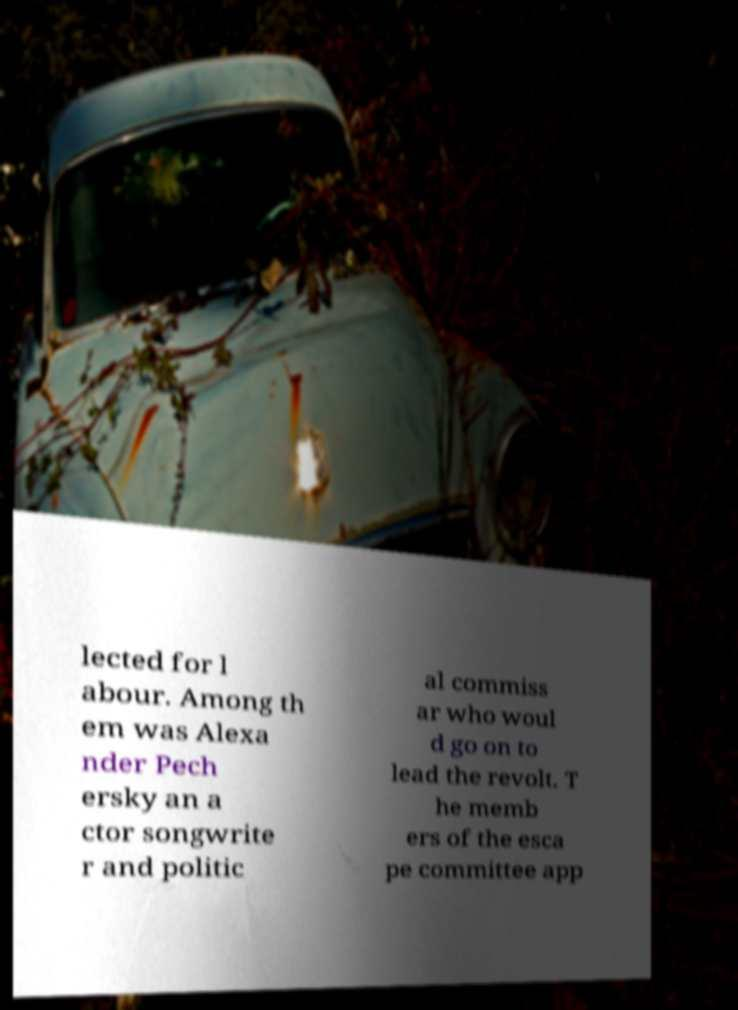For documentation purposes, I need the text within this image transcribed. Could you provide that? lected for l abour. Among th em was Alexa nder Pech ersky an a ctor songwrite r and politic al commiss ar who woul d go on to lead the revolt. T he memb ers of the esca pe committee app 